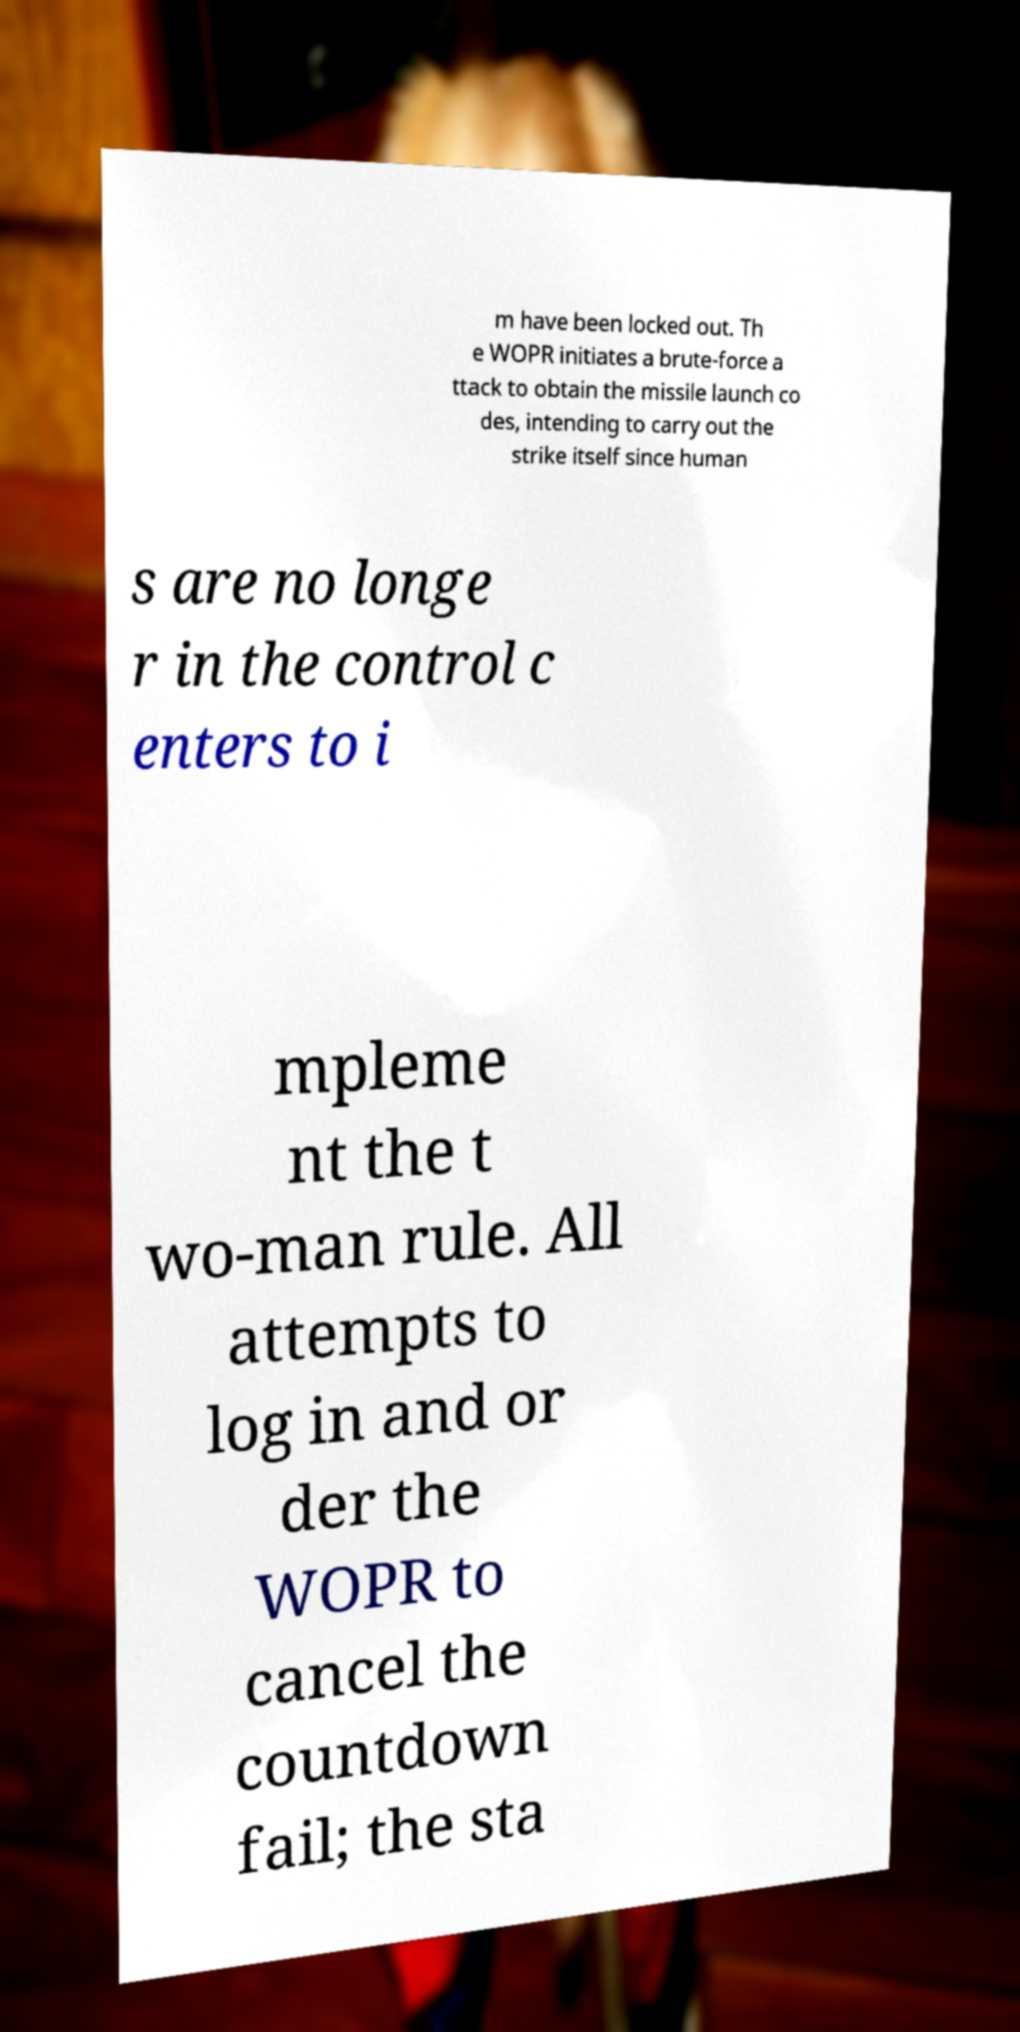Could you assist in decoding the text presented in this image and type it out clearly? m have been locked out. Th e WOPR initiates a brute-force a ttack to obtain the missile launch co des, intending to carry out the strike itself since human s are no longe r in the control c enters to i mpleme nt the t wo-man rule. All attempts to log in and or der the WOPR to cancel the countdown fail; the sta 